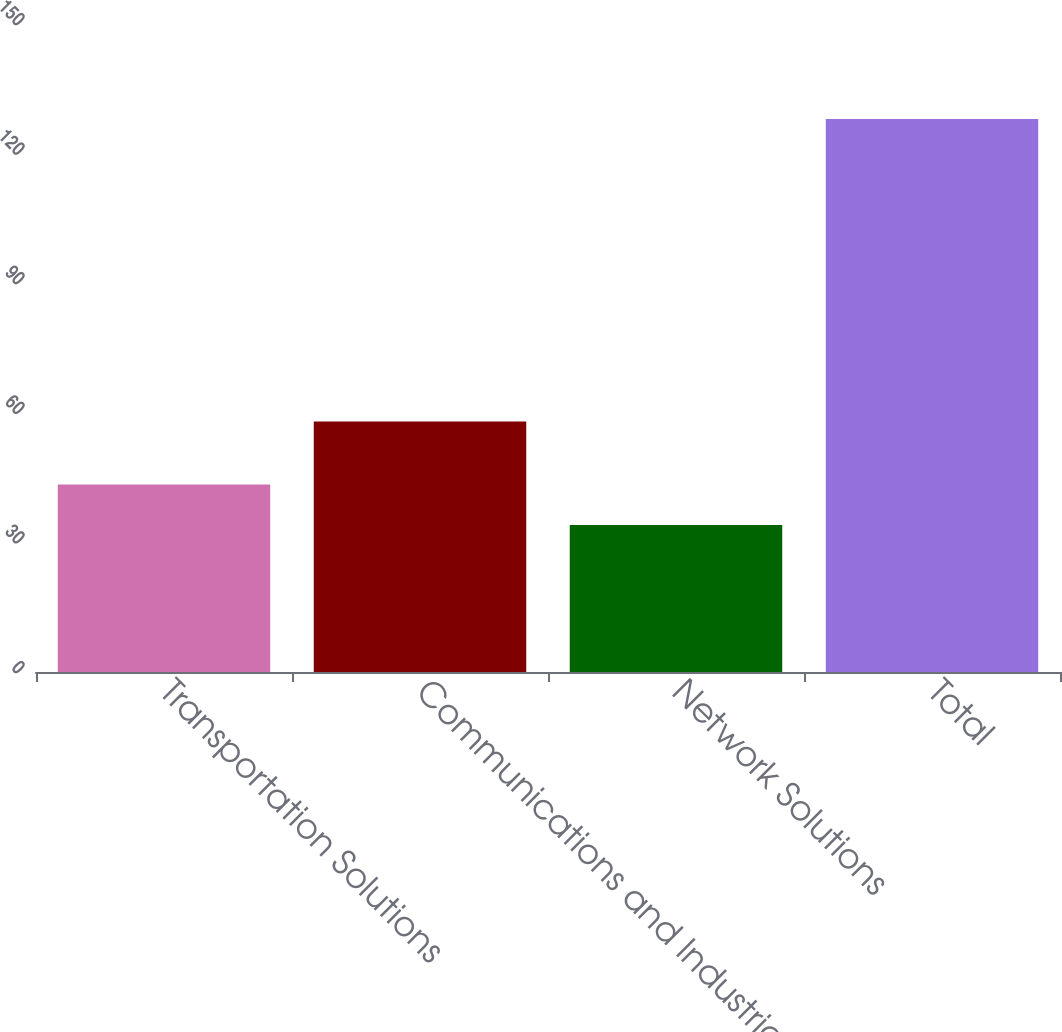Convert chart to OTSL. <chart><loc_0><loc_0><loc_500><loc_500><bar_chart><fcel>Transportation Solutions<fcel>Communications and Industrial<fcel>Network Solutions<fcel>Total<nl><fcel>43.4<fcel>58<fcel>34<fcel>128<nl></chart> 